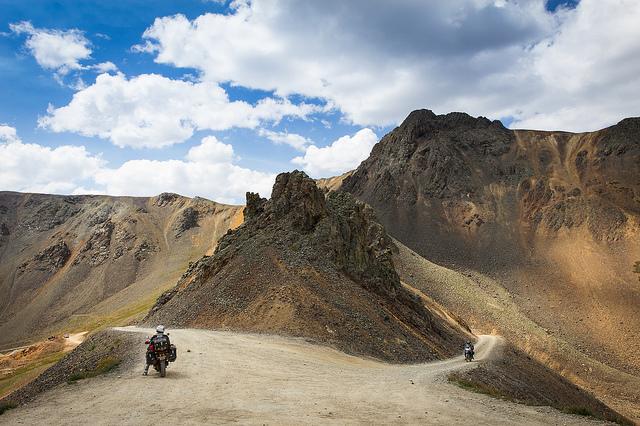Does the mountain have plants growing on it?
Short answer required. No. How many people are in the picture?
Short answer required. 1. Is that a person riding an elephant?
Give a very brief answer. No. How many motorcycles are on the dirt road?
Give a very brief answer. 2. 